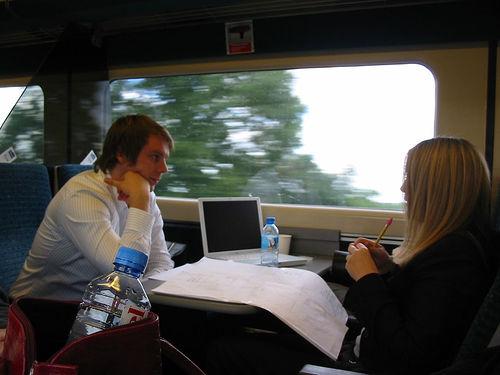What sort of transportation are these people making use of?
Write a very short answer. Train. Are these people on a train?
Be succinct. Yes. What is poking out of the bag in the foreground?
Concise answer only. Water bottle. Is this an interview?
Concise answer only. Yes. Is the screen on?
Give a very brief answer. No. 